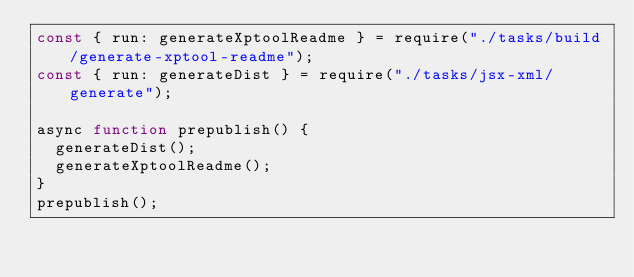<code> <loc_0><loc_0><loc_500><loc_500><_JavaScript_>const { run: generateXptoolReadme } = require("./tasks/build/generate-xptool-readme");
const { run: generateDist } = require("./tasks/jsx-xml/generate");

async function prepublish() {
  generateDist();
  generateXptoolReadme();
}
prepublish();
</code> 